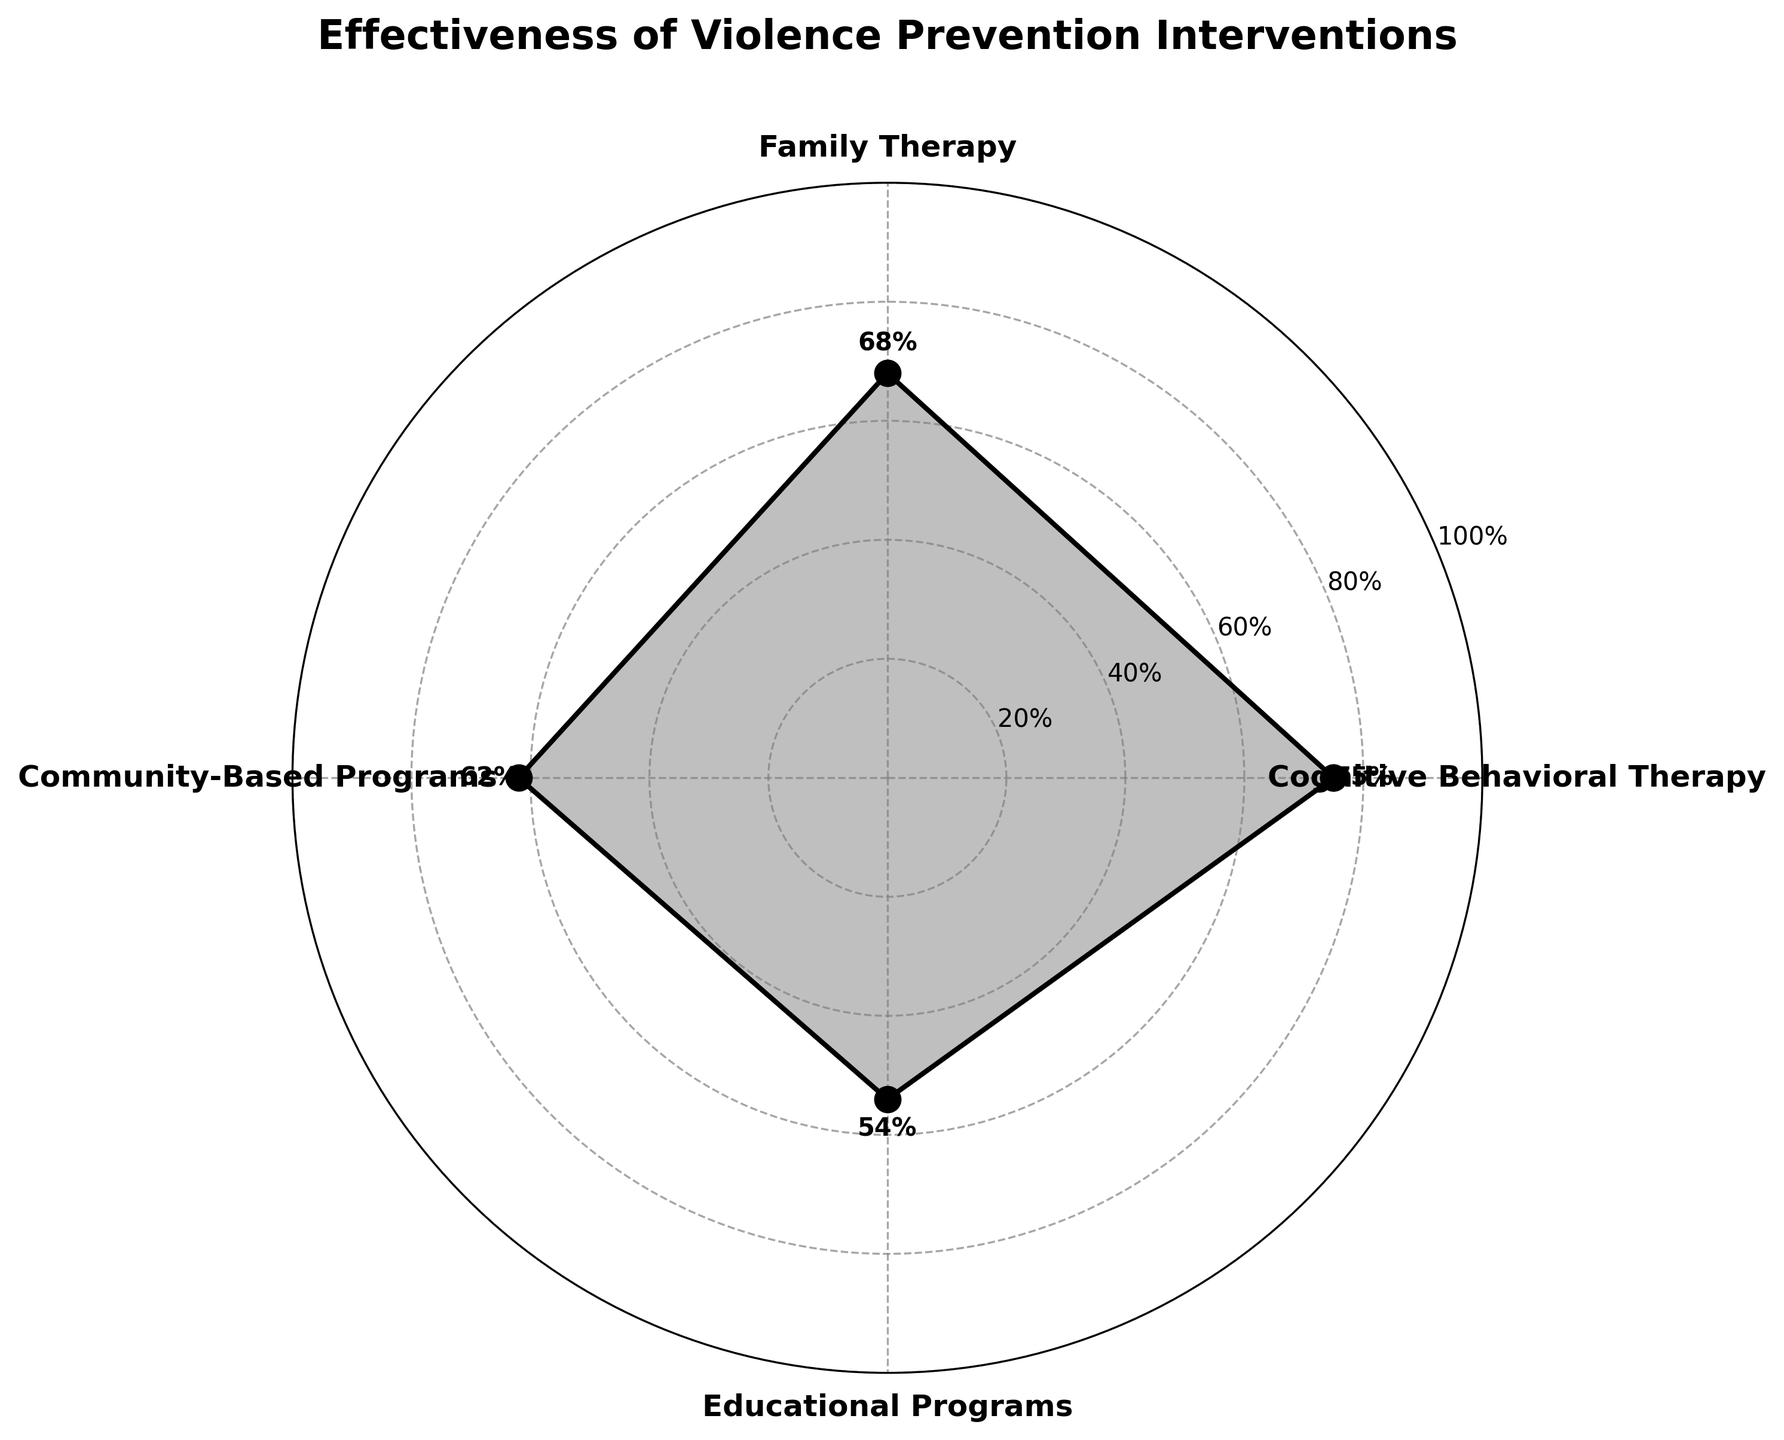What is the title of the chart? The title of the chart is displayed at the top, outside the plotted area, in bold and larger font size compared to other text elements.
Answer: Effectiveness of Violence Prevention Interventions How many different types of interventions are shown in the chart? The chart has labels for each category positioned around the circular plot. Counting these labels tells us the number of intervention types.
Answer: 4 Which intervention has the highest effectiveness percentage? By looking at the radial distance of the points from the center, the one with the largest distance corresponds to the highest effectiveness percentage.
Answer: Cognitive Behavioral Therapy Which intervention is the least effective according to the chart? The intervention with the smallest radial distance from the center has the lowest effectiveness percentage.
Answer: Educational Programs What is the difference in effectiveness between Family Therapy and Community-Based Programs? From the chart, Family Therapy has an effectiveness of 68% and Community-Based Programs have 62%. Subtract the lower value from the higher one.
Answer: 6% What is the average effectiveness percentage of all the interventions? Sum the effectiveness percentages of all interventions and divide by the number of interventions: (75 + 68 + 62 + 54) / 4.
Answer: 64.75% By how much does the effectiveness of Cognitive Behavioral Therapy exceed Educational Programs? Cognitive Behavioral Therapy has 75%, and Educational Programs have 54%. Subtract 54 from 75.
Answer: 21% Which two interventions have the closest effectiveness percentages? Compare the effectiveness percentages of each pair: Family Therapy (68%) and Community-Based Programs (62%) have a difference of 6%, which is the smallest difference.
Answer: Family Therapy and Community-Based Programs What radial percentage intervals are shown on the chart? The radial labels within the chart are the concentric circles labeled with percentage values.
Answer: 20%, 40%, 60%, 80%, 100% What is the combined effectiveness percentage of Cognitive Behavioral Therapy and Family Therapy? Sum the effectiveness percentages of Cognitive Behavioral Therapy (75%) and Family Therapy (68%).
Answer: 143% 